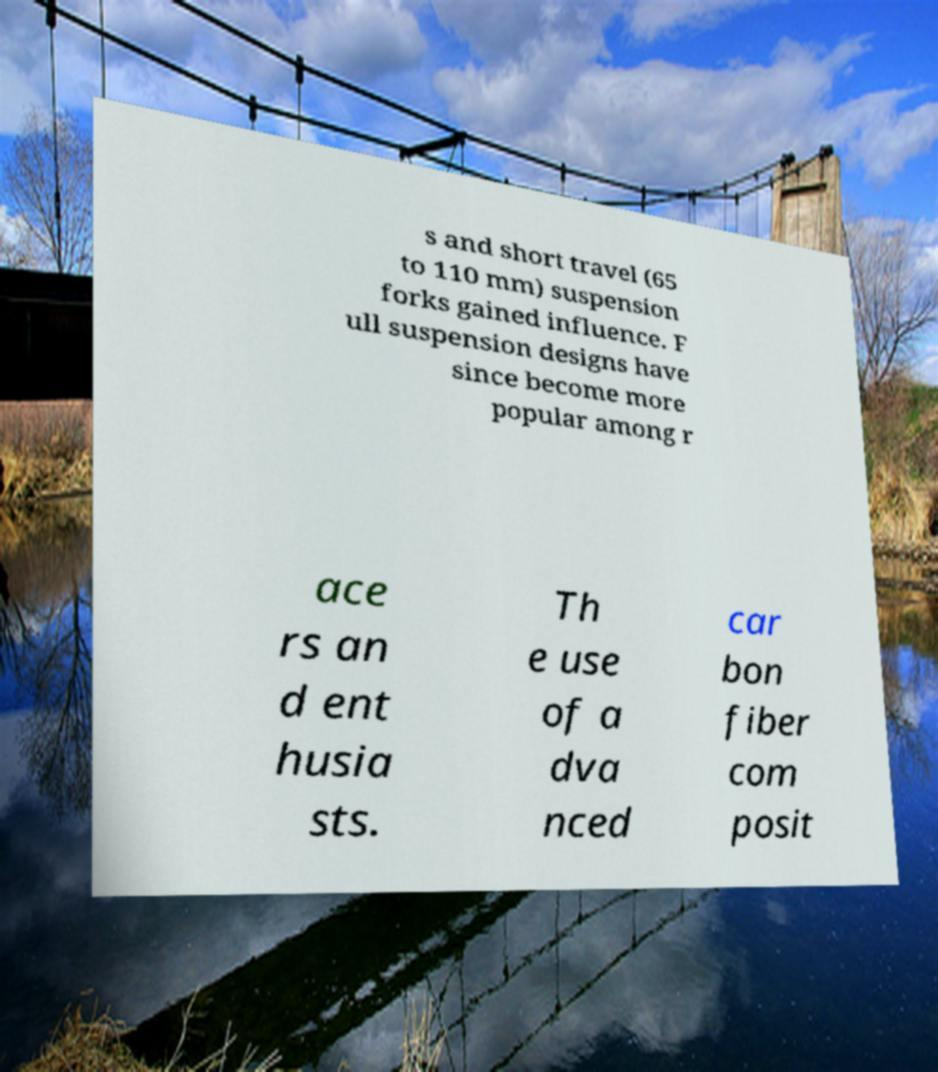Please read and relay the text visible in this image. What does it say? s and short travel (65 to 110 mm) suspension forks gained influence. F ull suspension designs have since become more popular among r ace rs an d ent husia sts. Th e use of a dva nced car bon fiber com posit 